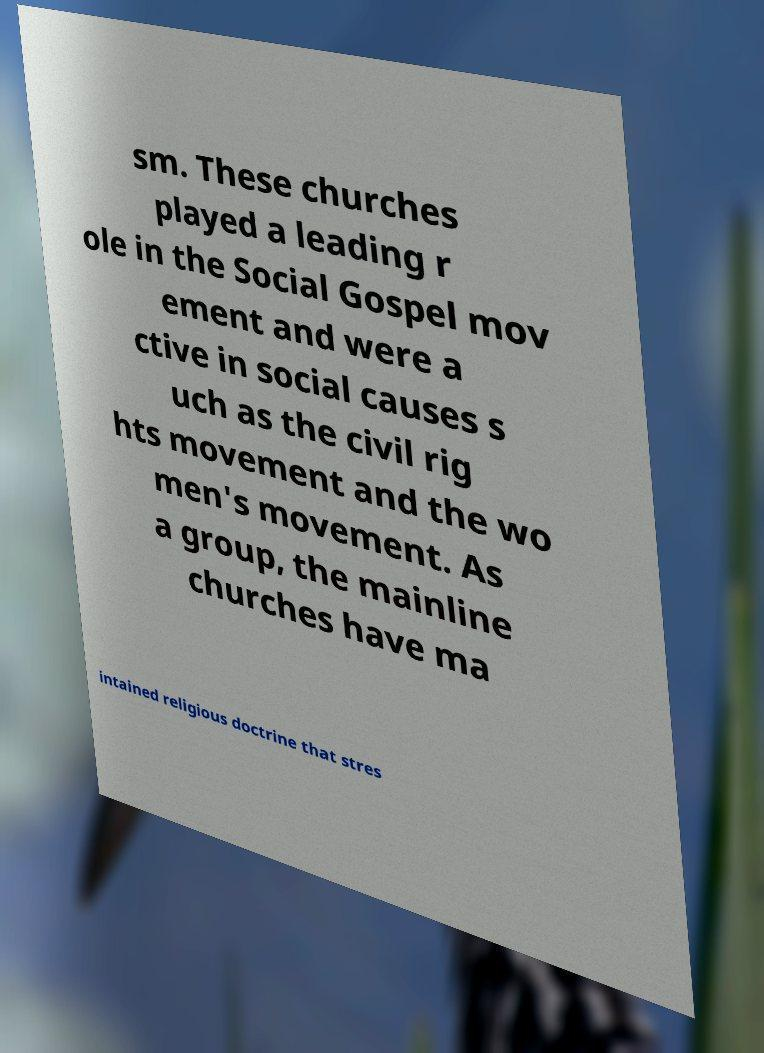Could you extract and type out the text from this image? sm. These churches played a leading r ole in the Social Gospel mov ement and were a ctive in social causes s uch as the civil rig hts movement and the wo men's movement. As a group, the mainline churches have ma intained religious doctrine that stres 